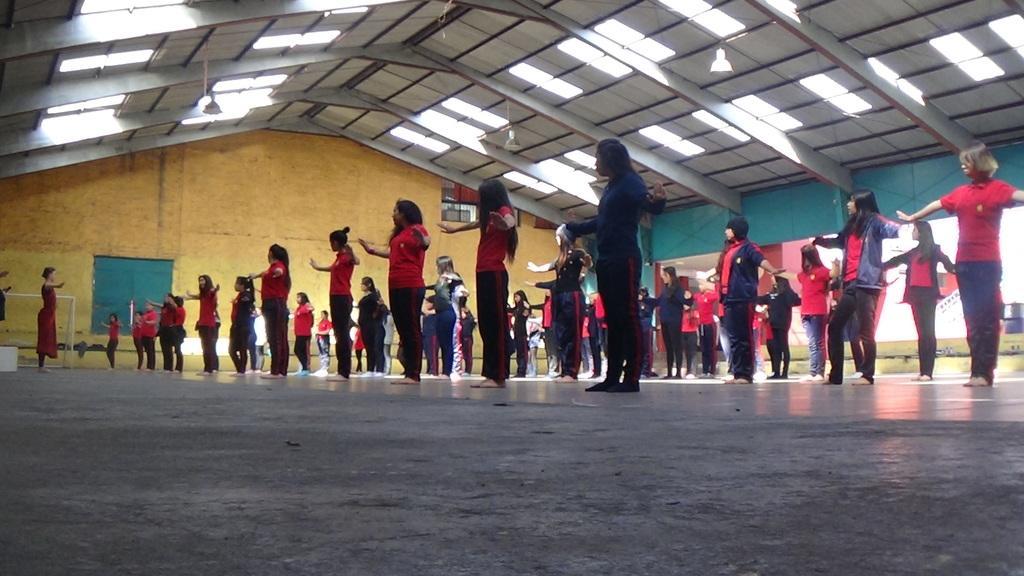Please provide a concise description of this image. In this picture we can see a group of people standing on the floor, wall, roof and some objects. 